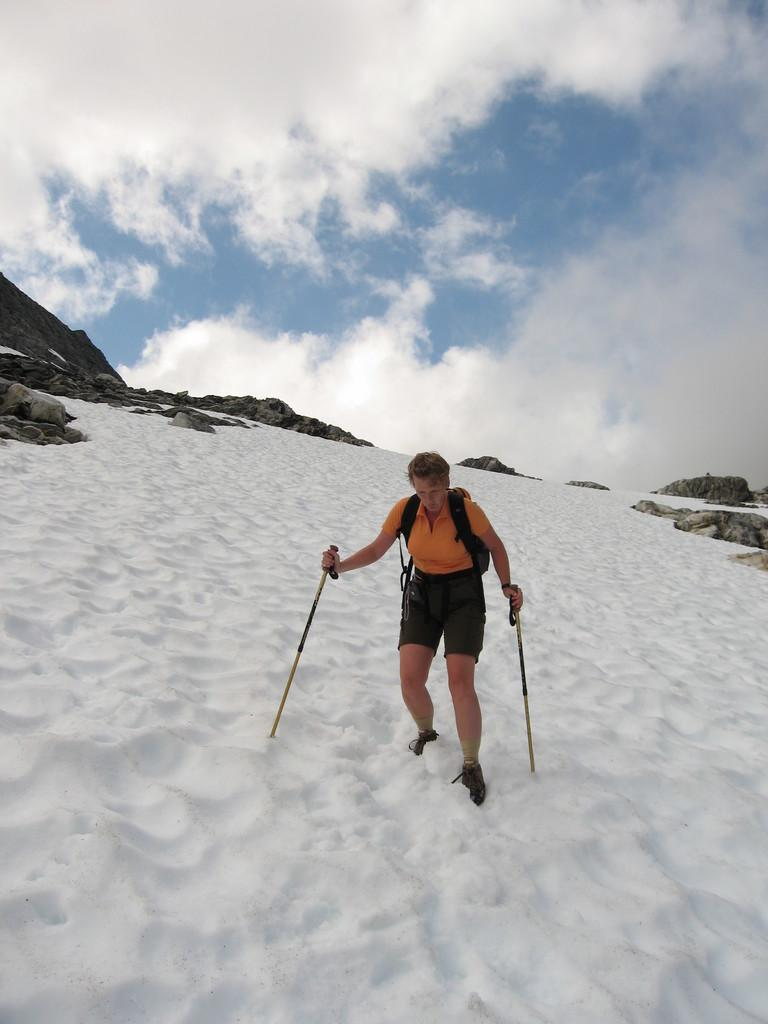Who is the main subject in the image? There is a woman in the image. What is the woman doing in the image? The woman is skating. Can you describe the woman's outfit in the image? The woman is wearing an orange top and shorts. What is the condition of the land in the image? The land is covered with snow. How would you describe the sky in the image? The sky is blue with clouds. What type of yarn is the woman using to skate in the image? There is no yarn present in the image; the woman is skating on snow. Is there a drain visible in the image? There is no drain present in the image. 